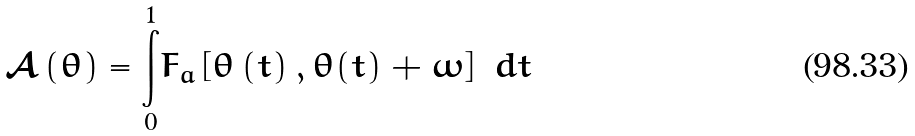<formula> <loc_0><loc_0><loc_500><loc_500>\mathcal { A } \left ( \theta \right ) = \overset { 1 } { \underset { 0 } { \int } } F _ { a } \left [ \theta \left ( t \right ) , \theta ( t ) + \omega \right ] \text { } d t</formula> 